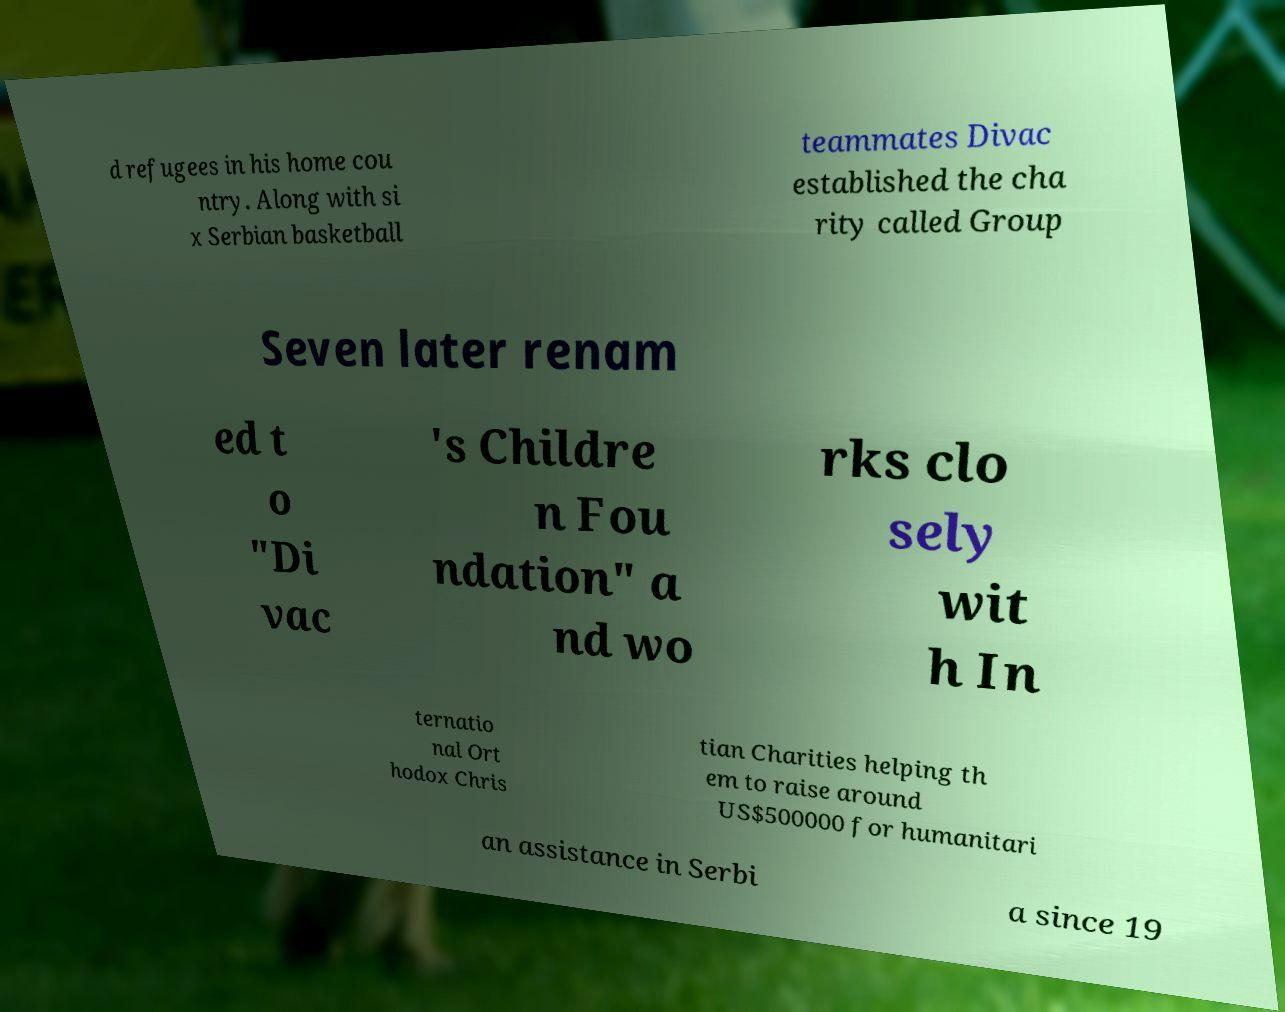Please identify and transcribe the text found in this image. d refugees in his home cou ntry. Along with si x Serbian basketball teammates Divac established the cha rity called Group Seven later renam ed t o "Di vac 's Childre n Fou ndation" a nd wo rks clo sely wit h In ternatio nal Ort hodox Chris tian Charities helping th em to raise around US$500000 for humanitari an assistance in Serbi a since 19 